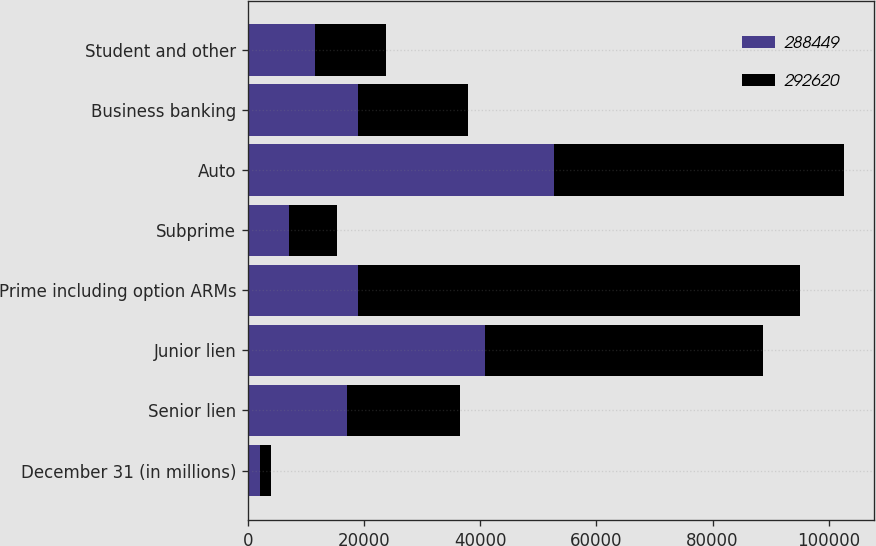Convert chart to OTSL. <chart><loc_0><loc_0><loc_500><loc_500><stacked_bar_chart><ecel><fcel>December 31 (in millions)<fcel>Senior lien<fcel>Junior lien<fcel>Prime including option ARMs<fcel>Subprime<fcel>Auto<fcel>Business banking<fcel>Student and other<nl><fcel>288449<fcel>2013<fcel>17113<fcel>40750<fcel>18883<fcel>7104<fcel>52757<fcel>18951<fcel>11557<nl><fcel>292620<fcel>2012<fcel>19385<fcel>48000<fcel>76256<fcel>8255<fcel>49913<fcel>18883<fcel>12191<nl></chart> 